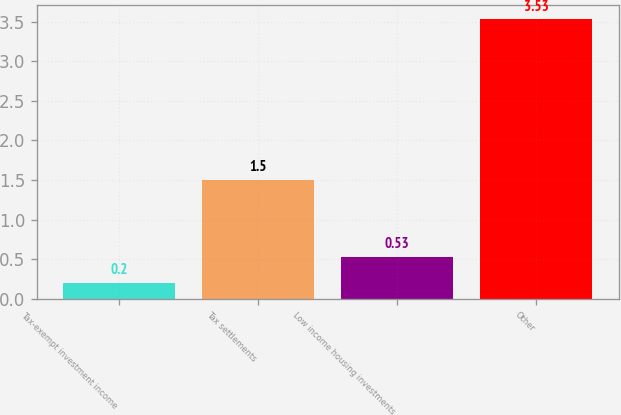Convert chart to OTSL. <chart><loc_0><loc_0><loc_500><loc_500><bar_chart><fcel>Tax-exempt investment income<fcel>Tax settlements<fcel>Low income housing investments<fcel>Other<nl><fcel>0.2<fcel>1.5<fcel>0.53<fcel>3.53<nl></chart> 